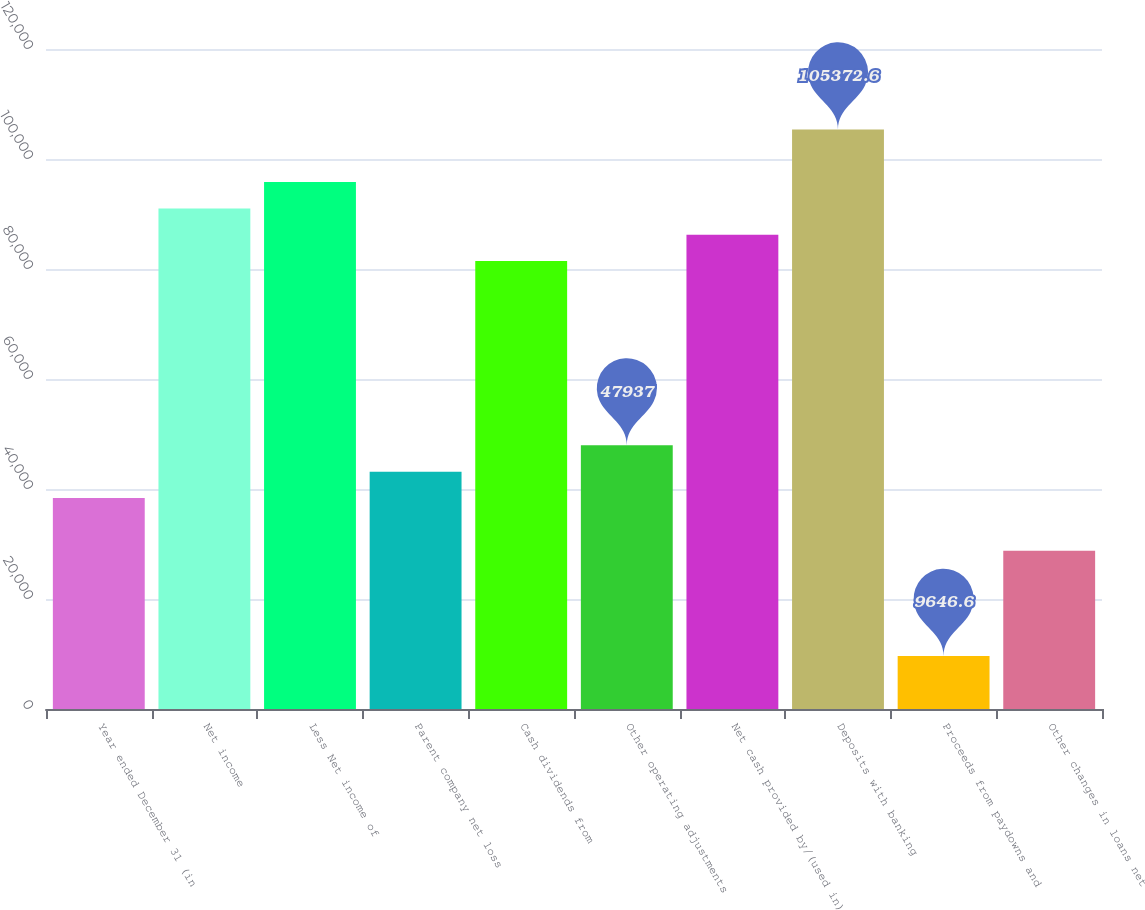Convert chart. <chart><loc_0><loc_0><loc_500><loc_500><bar_chart><fcel>Year ended December 31 (in<fcel>Net income<fcel>Less Net income of<fcel>Parent company net loss<fcel>Cash dividends from<fcel>Other operating adjustments<fcel>Net cash provided by/(used in)<fcel>Deposits with banking<fcel>Proceeds from paydowns and<fcel>Other changes in loans net<nl><fcel>38364.4<fcel>91013.7<fcel>95800<fcel>43150.7<fcel>81441.1<fcel>47937<fcel>86227.4<fcel>105373<fcel>9646.6<fcel>28791.8<nl></chart> 